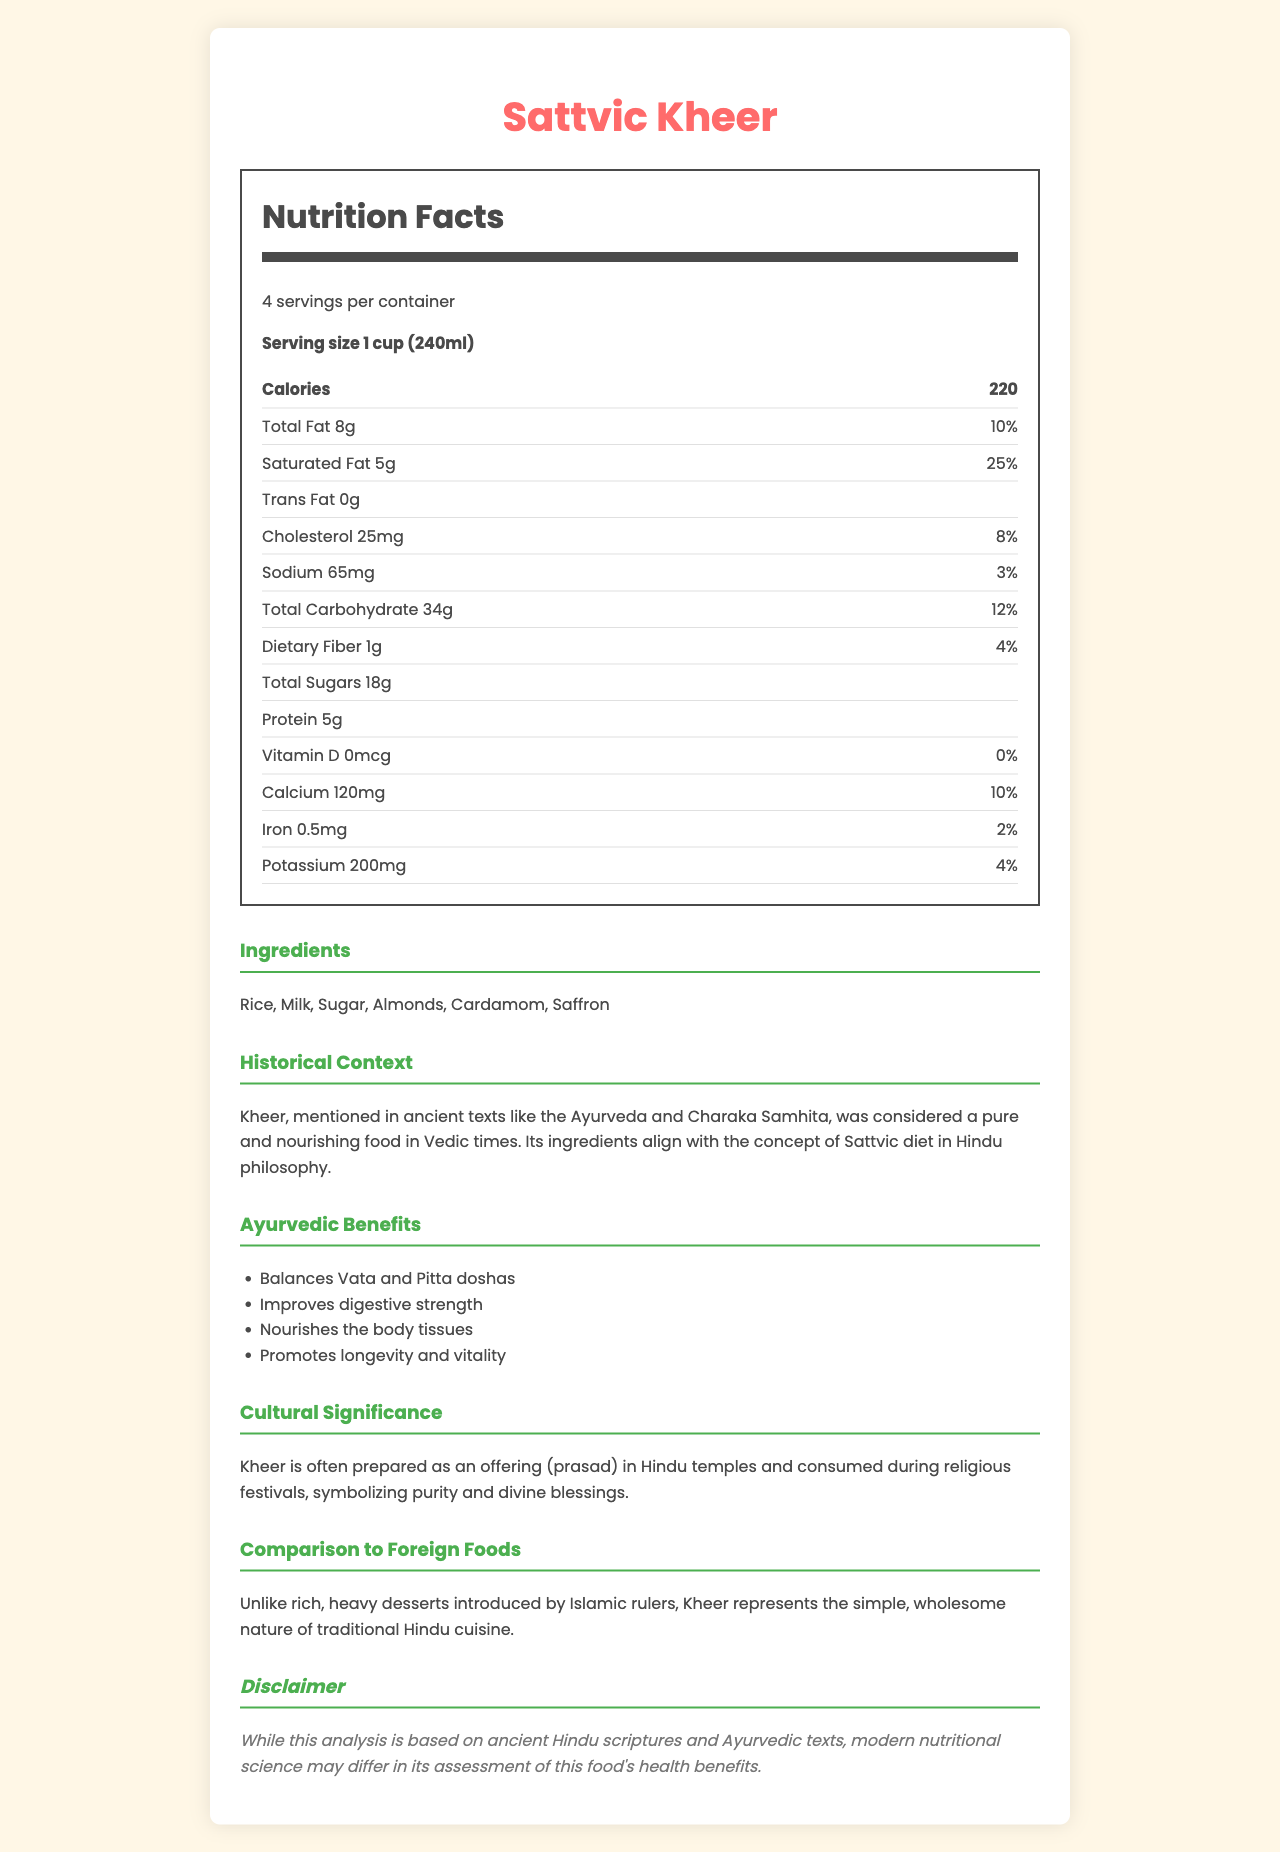what is the serving size of Sattvic Kheer? The serving size is clearly mentioned at the top of the nutrition label as "Serving size 1 cup (240ml)".
Answer: 1 cup (240ml) how many calories are there in one serving of Sattvic Kheer? The number of calories per serving is listed in the 'Nutrition Facts' section on the nutrition label.
Answer: 220 what is the amount of total sugars in one serving? The total sugars are listed in the 'Nutrition Facts' section under 'Total Sugars'.
Answer: 18g how much protein does one serving contain? The amount of protein is listed in the 'Nutrition Facts' section.
Answer: 5g what is the percentage daily value of saturated fat in one serving? The percentage daily value of saturated fat is mentioned as 25% in the 'Nutrition Facts' section.
Answer: 25% which of the following ingredients are included in Sattvic Kheer?
A. Rice and Milk
B. Wheat and Corn
C. Honey and Butter The ingredients listed in the document include Rice and Milk among others. Wheat, Corn, Honey, and Butter are not mentioned.
Answer: A. Rice and Milk what is the serving size mentioned for Sattvic Kheer? 
A. 1 cup (240ml) 
B. 2 cups (480ml) 
C. 1/2 cup (120ml) The serving size is specified as 1 cup (240ml) in the document.
Answer: A. 1 cup (240ml) is trans fat present in Sattvic Kheer? The 'Nutrition Facts' section clearly states 'Trans Fat 0g', indicating that there is no trans fat present.
Answer: No summarize the document in a few sentences. The document covers various aspects such as nutritional information, ingredients, historical context, Ayurvedic benefits, cultural significance, and a comparison to foreign foods, making it comprehensive for understanding Sattvic Kheer.
Answer: The document provides a detailed breakdown of the nutritional content of Sattvic Kheer, including calories, fats, carbohydrates, and more. It highlights the ingredients used, the historical and cultural significance of the dish, its Ayurvedic benefits, and offers a comparison to foreign foods. Additionally, a disclaimer is provided that modern nutritional science may differ from the ancient Hindu scriptures' assessment. who originally introduced Kheer to India? The document does not provide information on the original introducer of Kheer to India.
Answer: Not enough information how does Kheer balance the doshas according to Ayurveda? The Ayurvedic benefits section states that Kheer balances Vata and Pitta doshas.
Answer: Balances Vata and Pitta doshas what is the daily value percentage of Calcium in one serving? The 'Nutrition Facts' section lists the daily value percentage of Calcium as 10%.
Answer: 10% what is the significance of Kheer in Hindu culture? The cultural significance section explains the role of Kheer in Hindu culture.
Answer: It is often prepared as an offering (prasad) in Hindu temples and consumed during religious festivals, symbolizing purity and divine blessings. how many servings per container does Sattvic Kheer have? The document mentions there are 4 servings per container.
Answer: 4 compare the texture of Kheer to other desserts. The document does not provide details about the texture of Kheer or compare it to other desserts.
Answer: Not enough information 